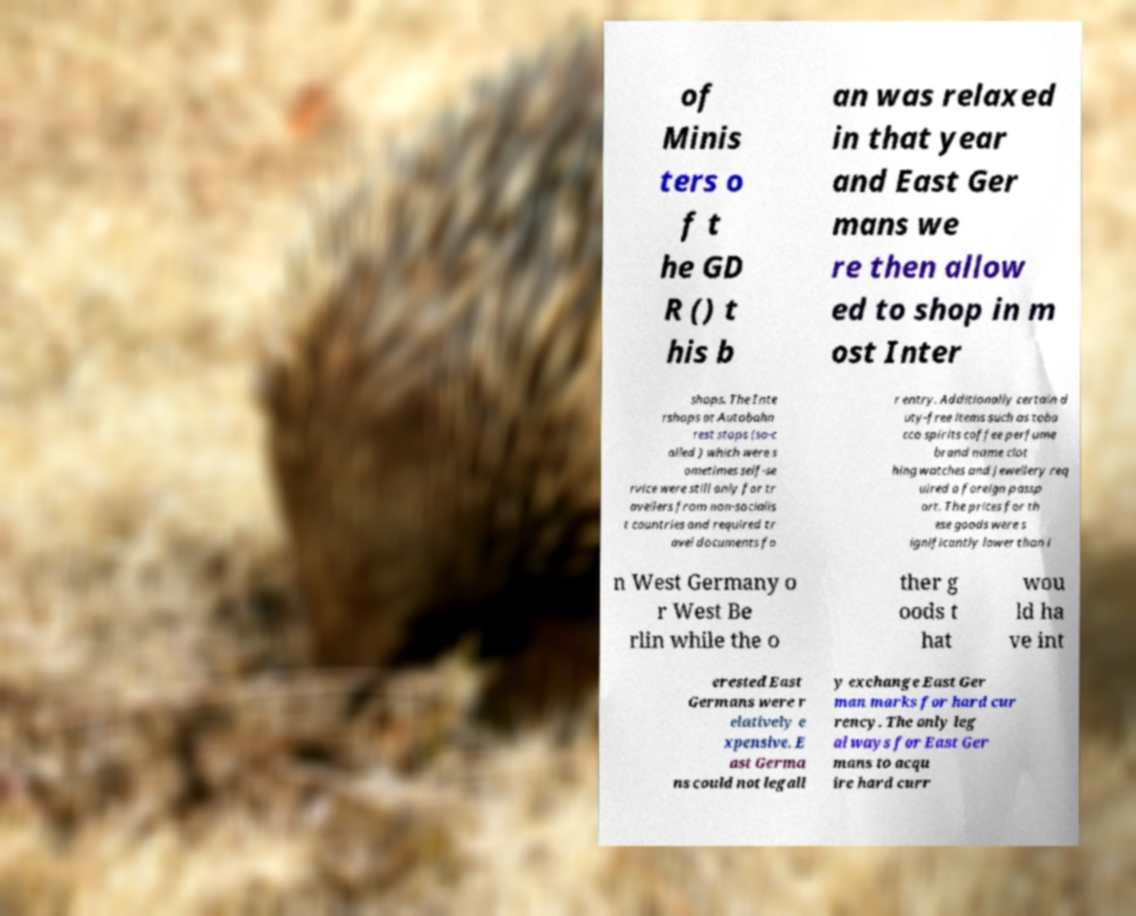Please identify and transcribe the text found in this image. of Minis ters o f t he GD R () t his b an was relaxed in that year and East Ger mans we re then allow ed to shop in m ost Inter shops. The Inte rshops at Autobahn rest stops (so-c alled ) which were s ometimes self-se rvice were still only for tr avellers from non-socialis t countries and required tr avel documents fo r entry. Additionally certain d uty-free items such as toba cco spirits coffee perfume brand name clot hing watches and jewellery req uired a foreign passp ort. The prices for th ese goods were s ignificantly lower than i n West Germany o r West Be rlin while the o ther g oods t hat wou ld ha ve int erested East Germans were r elatively e xpensive. E ast Germa ns could not legall y exchange East Ger man marks for hard cur rency. The only leg al ways for East Ger mans to acqu ire hard curr 